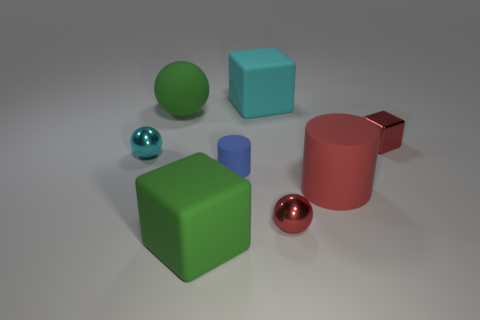There is a tiny sphere on the left side of the large cyan matte cube; how many tiny cyan objects are in front of it?
Your answer should be very brief. 0. Is the number of small shiny balls that are on the left side of the big cyan rubber block less than the number of red metal objects?
Ensure brevity in your answer.  Yes. Are there any cubes that are on the right side of the big cube that is on the right side of the large green object that is in front of the red block?
Your answer should be compact. Yes. Do the small red ball and the ball behind the small cyan shiny ball have the same material?
Provide a succinct answer. No. What color is the tiny metallic object that is in front of the sphere to the left of the big green ball?
Provide a succinct answer. Red. Are there any large cubes of the same color as the large cylinder?
Ensure brevity in your answer.  No. There is a rubber cylinder on the left side of the red matte thing that is behind the green rubber object in front of the red metal block; what size is it?
Give a very brief answer. Small. There is a cyan rubber object; is its shape the same as the green rubber thing that is in front of the tiny cylinder?
Provide a short and direct response. Yes. What number of other objects are the same size as the cyan metallic ball?
Offer a terse response. 3. There is a matte cylinder that is in front of the blue matte cylinder; what is its size?
Your answer should be compact. Large. 